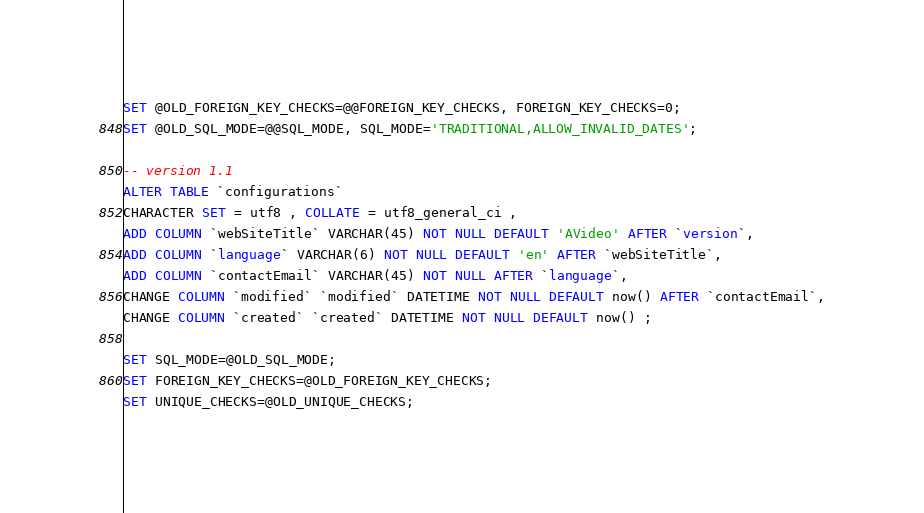Convert code to text. <code><loc_0><loc_0><loc_500><loc_500><_SQL_>SET @OLD_FOREIGN_KEY_CHECKS=@@FOREIGN_KEY_CHECKS, FOREIGN_KEY_CHECKS=0;
SET @OLD_SQL_MODE=@@SQL_MODE, SQL_MODE='TRADITIONAL,ALLOW_INVALID_DATES';

-- version 1.1
ALTER TABLE `configurations` 
CHARACTER SET = utf8 , COLLATE = utf8_general_ci ,
ADD COLUMN `webSiteTitle` VARCHAR(45) NOT NULL DEFAULT 'AVideo' AFTER `version`,
ADD COLUMN `language` VARCHAR(6) NOT NULL DEFAULT 'en' AFTER `webSiteTitle`,
ADD COLUMN `contactEmail` VARCHAR(45) NOT NULL AFTER `language`,
CHANGE COLUMN `modified` `modified` DATETIME NOT NULL DEFAULT now() AFTER `contactEmail`,
CHANGE COLUMN `created` `created` DATETIME NOT NULL DEFAULT now() ;

SET SQL_MODE=@OLD_SQL_MODE;
SET FOREIGN_KEY_CHECKS=@OLD_FOREIGN_KEY_CHECKS;
SET UNIQUE_CHECKS=@OLD_UNIQUE_CHECKS;</code> 